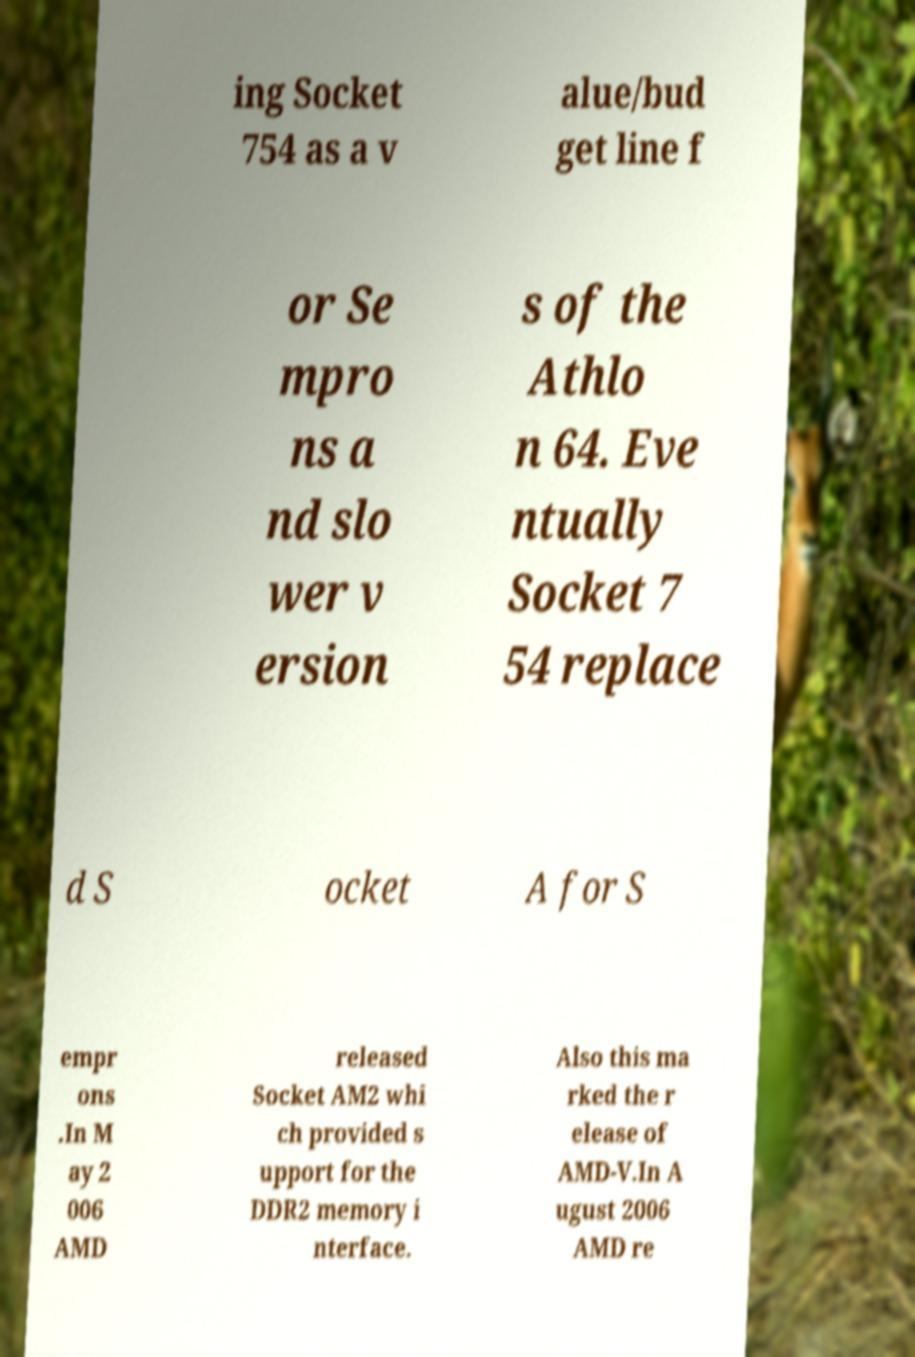There's text embedded in this image that I need extracted. Can you transcribe it verbatim? ing Socket 754 as a v alue/bud get line f or Se mpro ns a nd slo wer v ersion s of the Athlo n 64. Eve ntually Socket 7 54 replace d S ocket A for S empr ons .In M ay 2 006 AMD released Socket AM2 whi ch provided s upport for the DDR2 memory i nterface. Also this ma rked the r elease of AMD-V.In A ugust 2006 AMD re 